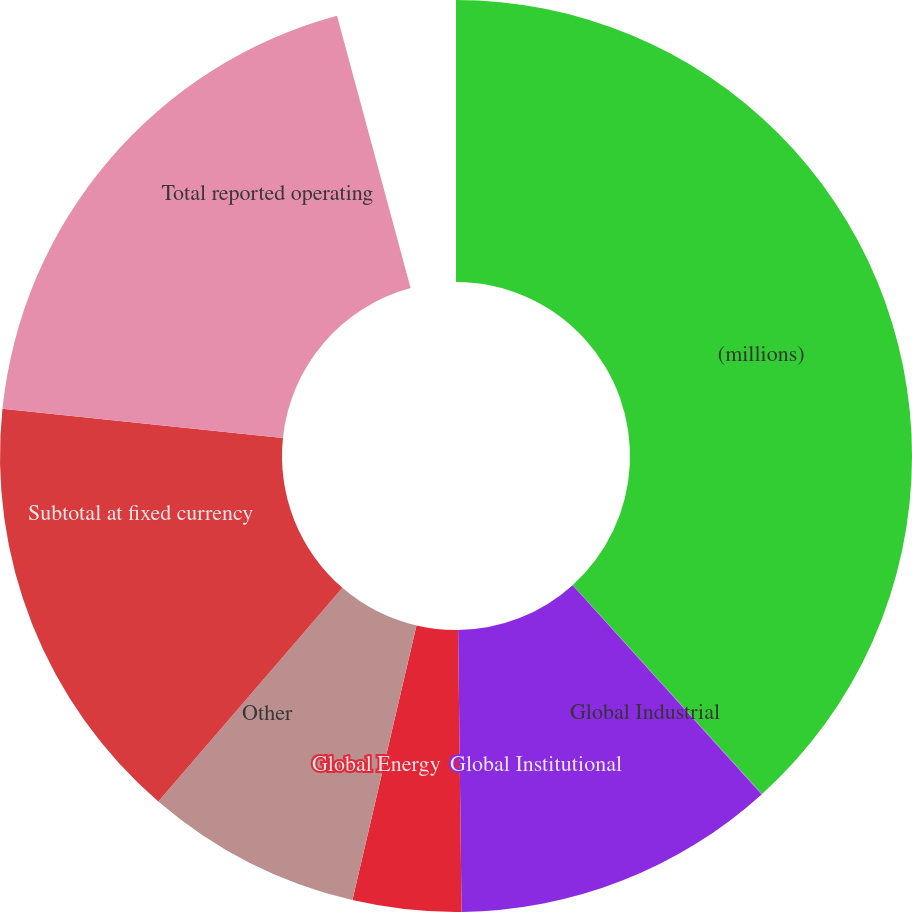<chart> <loc_0><loc_0><loc_500><loc_500><pie_chart><fcel>(millions)<fcel>Global Industrial<fcel>Global Institutional<fcel>Global Energy<fcel>Other<fcel>Subtotal at fixed currency<fcel>Total reported operating<nl><fcel>39.97%<fcel>0.02%<fcel>12.0%<fcel>4.01%<fcel>8.01%<fcel>16.0%<fcel>19.99%<nl></chart> 